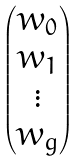<formula> <loc_0><loc_0><loc_500><loc_500>\begin{pmatrix} w _ { 0 } \\ w _ { 1 } \\ \vdots \\ w _ { g } \end{pmatrix}</formula> 